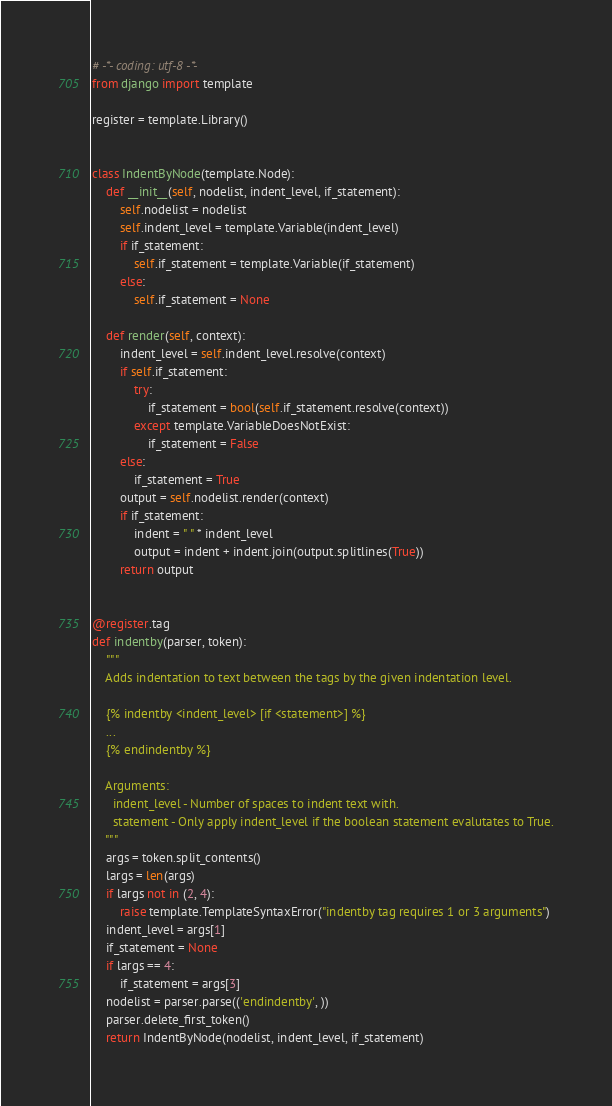Convert code to text. <code><loc_0><loc_0><loc_500><loc_500><_Python_># -*- coding: utf-8 -*-
from django import template

register = template.Library()


class IndentByNode(template.Node):
    def __init__(self, nodelist, indent_level, if_statement):
        self.nodelist = nodelist
        self.indent_level = template.Variable(indent_level)
        if if_statement:
            self.if_statement = template.Variable(if_statement)
        else:
            self.if_statement = None

    def render(self, context):
        indent_level = self.indent_level.resolve(context)
        if self.if_statement:
            try:
                if_statement = bool(self.if_statement.resolve(context))
            except template.VariableDoesNotExist:
                if_statement = False
        else:
            if_statement = True
        output = self.nodelist.render(context)
        if if_statement:
            indent = " " * indent_level
            output = indent + indent.join(output.splitlines(True))
        return output


@register.tag
def indentby(parser, token):
    """
    Adds indentation to text between the tags by the given indentation level.

    {% indentby <indent_level> [if <statement>] %}
    ...
    {% endindentby %}

    Arguments:
      indent_level - Number of spaces to indent text with.
      statement - Only apply indent_level if the boolean statement evalutates to True.
    """
    args = token.split_contents()
    largs = len(args)
    if largs not in (2, 4):
        raise template.TemplateSyntaxError("indentby tag requires 1 or 3 arguments")
    indent_level = args[1]
    if_statement = None
    if largs == 4:
        if_statement = args[3]
    nodelist = parser.parse(('endindentby', ))
    parser.delete_first_token()
    return IndentByNode(nodelist, indent_level, if_statement)
</code> 